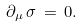Convert formula to latex. <formula><loc_0><loc_0><loc_500><loc_500>\partial _ { \mu } \, \sigma \, = \, 0 .</formula> 